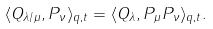Convert formula to latex. <formula><loc_0><loc_0><loc_500><loc_500>\langle Q _ { \lambda / \mu } , P _ { \nu } \rangle _ { q , t } = \langle Q _ { \lambda } , P _ { \mu } P _ { \nu } \rangle _ { q , t } .</formula> 